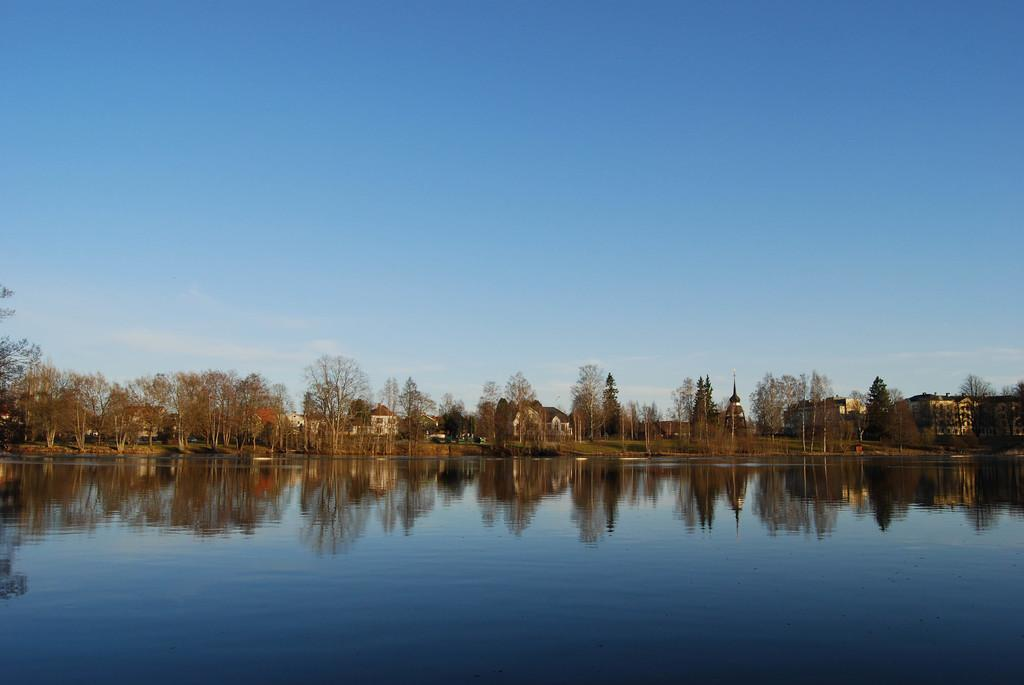What is located in the middle of the image? There is water in the middle of the image. What can be seen in the background of the image? There are houses and trees in the background of the image. How is the sky represented in the image? The sky is visible at the top of the image. What is reflected on the water in the image? There are reflections on the water in the image. What type of juice can be seen being squeezed from the root in the image? There is no juice or root present in the image. Can you tell me how many kitties are playing on the roof of the houses in the image? There are no kitties present in the image; only houses, trees, and water are visible. 